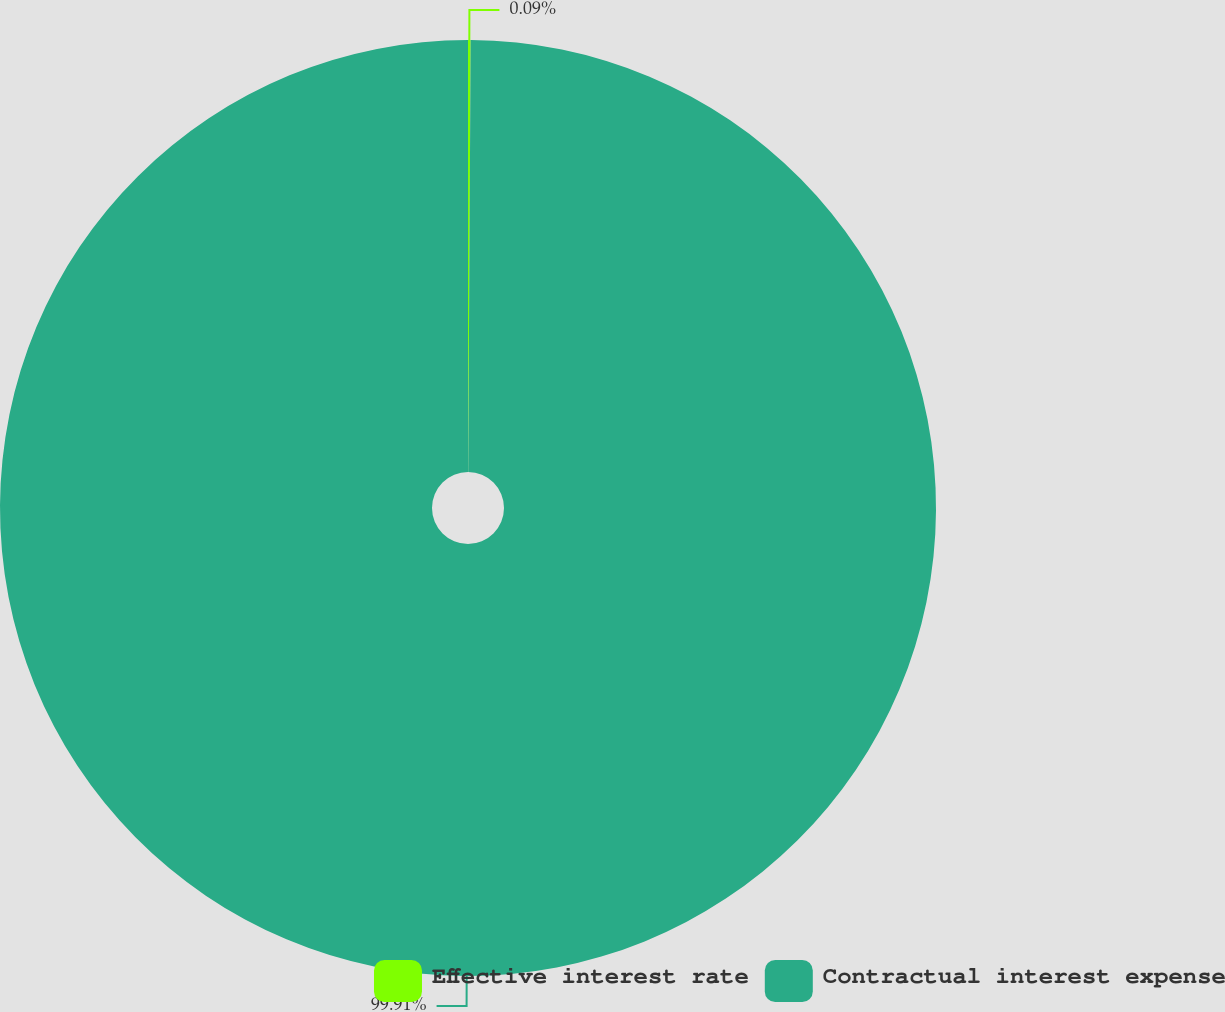<chart> <loc_0><loc_0><loc_500><loc_500><pie_chart><fcel>Effective interest rate<fcel>Contractual interest expense<nl><fcel>0.09%<fcel>99.91%<nl></chart> 